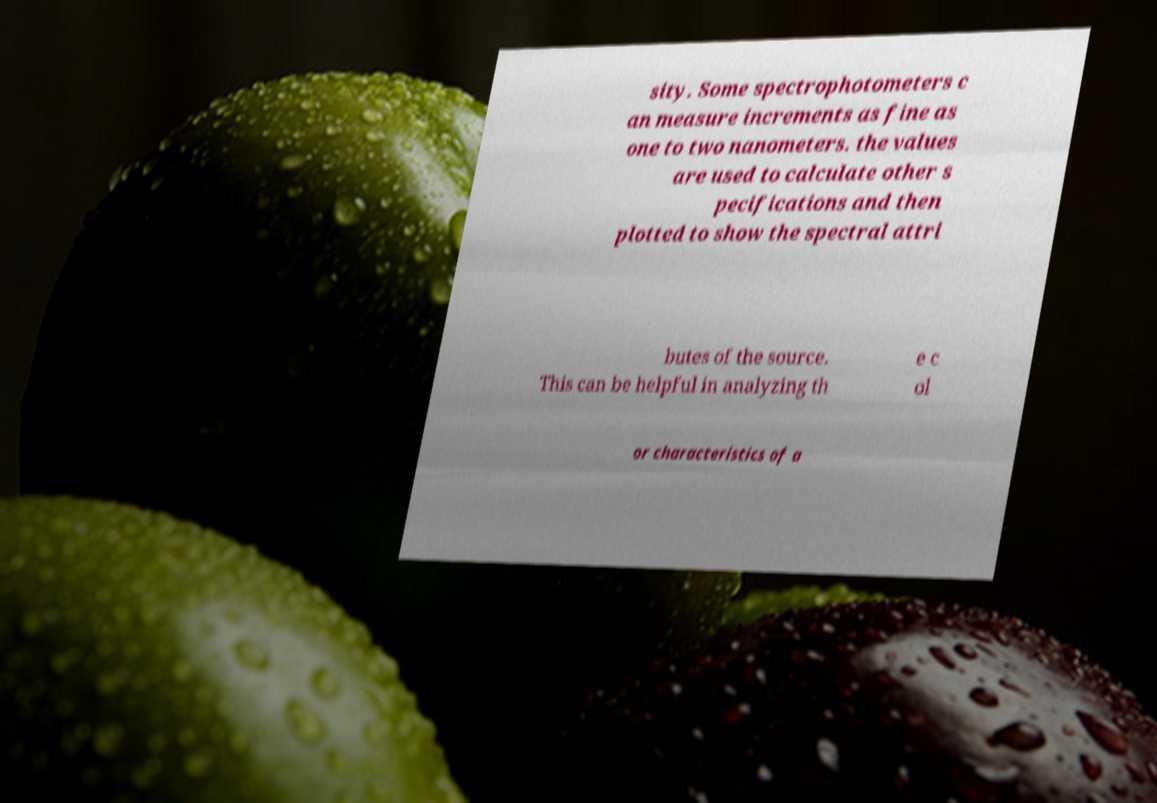There's text embedded in this image that I need extracted. Can you transcribe it verbatim? sity. Some spectrophotometers c an measure increments as fine as one to two nanometers. the values are used to calculate other s pecifications and then plotted to show the spectral attri butes of the source. This can be helpful in analyzing th e c ol or characteristics of a 